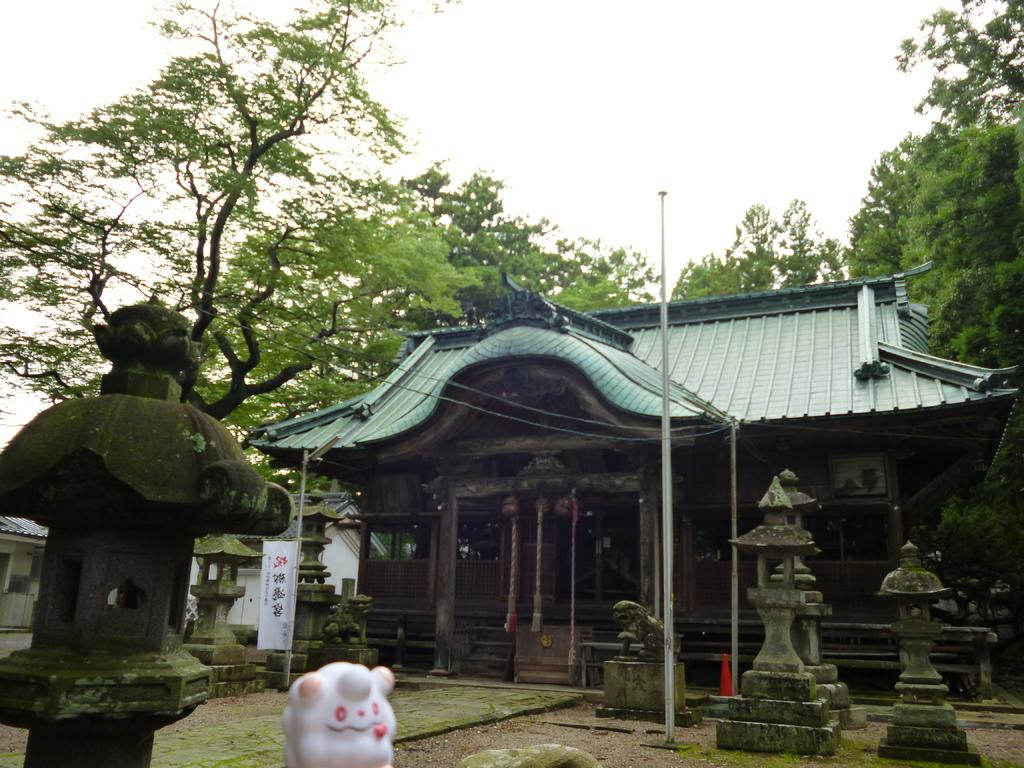What is the main structure in the image? There is a house in the image. What type of object can be seen near the house? There is a pole in the image. What are the colors of the objects in the image? There is a white color object in the image. What architectural features are present in the image? There are boards, pillars, and a house in the image. What type of vegetation can be seen in the image? There are trees in the image. What is visible in the background of the image? The sky is visible in the background of the image. What type of lunch is being served in the image? There is no lunch present in the image. What word is written on the boards in the image? There is no word written on the boards in the image. 